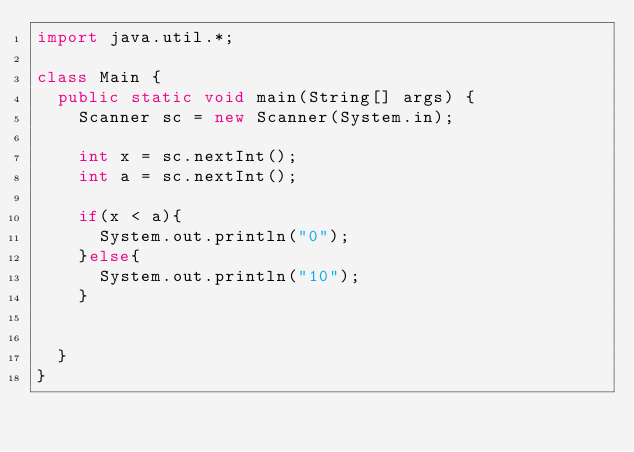<code> <loc_0><loc_0><loc_500><loc_500><_Java_>import java.util.*;
 
class Main {
  public static void main(String[] args) {
    Scanner sc = new Scanner(System.in);
    
    int x = sc.nextInt();
    int a = sc.nextInt();
    
	if(x < a){
      System.out.println("0");
    }else{
      System.out.println("10");
    }
 
 
  }
}</code> 